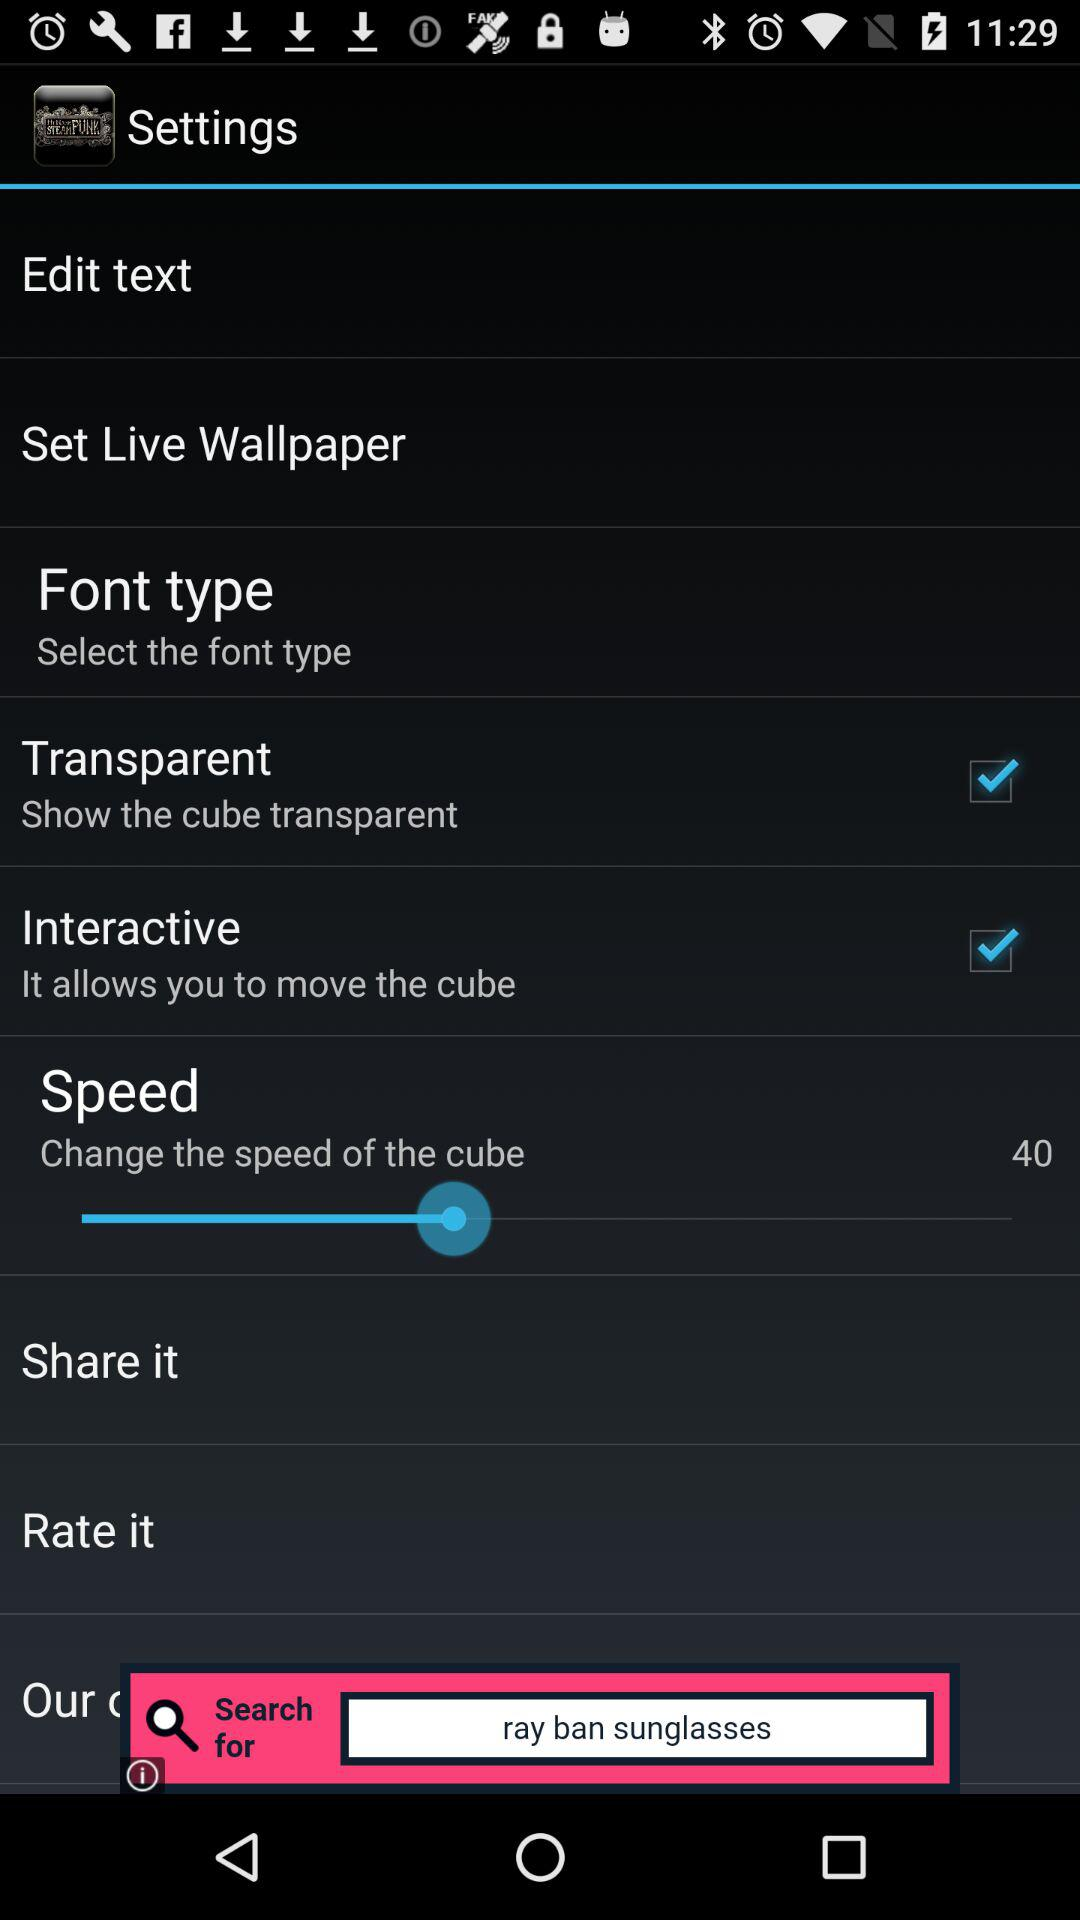How many checkboxes are in the settings menu?
Answer the question using a single word or phrase. 2 